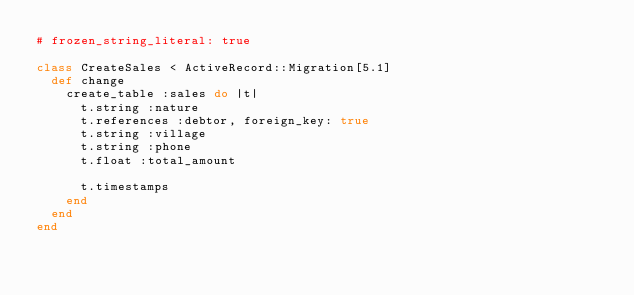<code> <loc_0><loc_0><loc_500><loc_500><_Ruby_># frozen_string_literal: true

class CreateSales < ActiveRecord::Migration[5.1]
  def change
    create_table :sales do |t|
      t.string :nature
      t.references :debtor, foreign_key: true
      t.string :village
      t.string :phone
      t.float :total_amount

      t.timestamps
    end
  end
end
</code> 